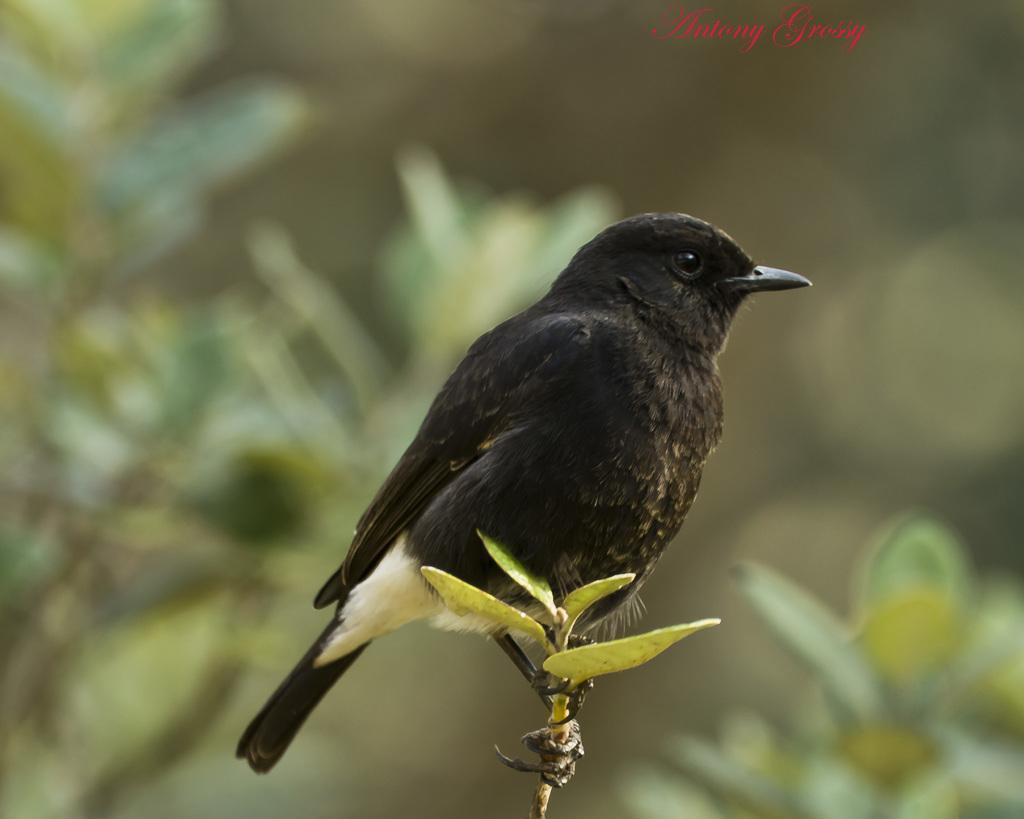In one or two sentences, can you explain what this image depicts? In this image we can see a black color bird and the background is blurry with some leaves. At the top there is a red color text. 